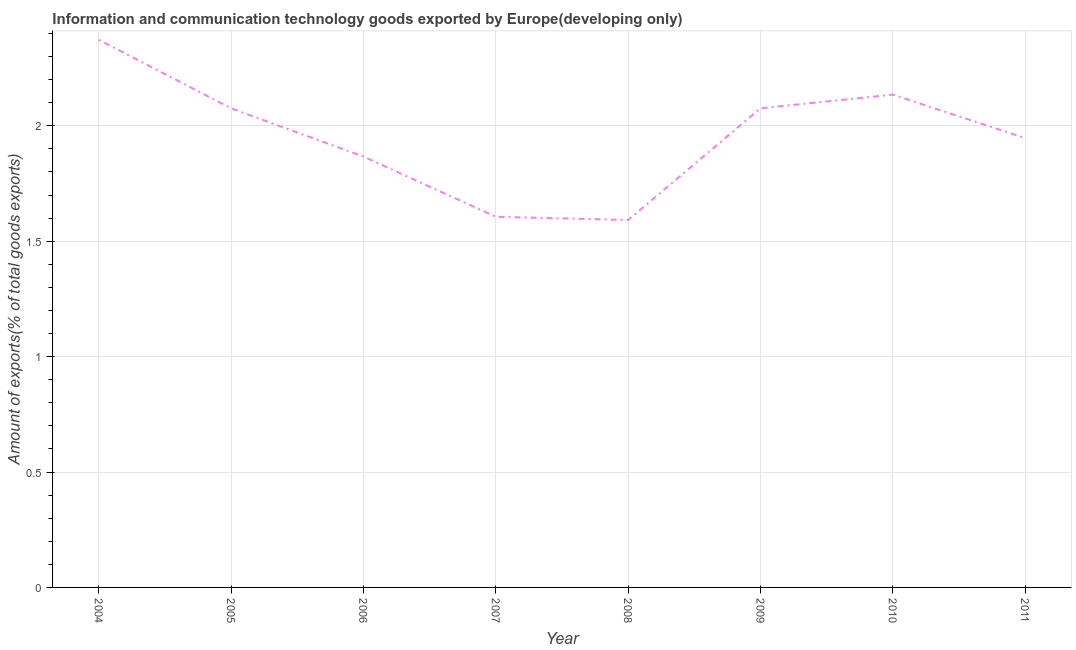What is the amount of ict goods exports in 2008?
Give a very brief answer. 1.59. Across all years, what is the maximum amount of ict goods exports?
Offer a very short reply. 2.37. Across all years, what is the minimum amount of ict goods exports?
Offer a terse response. 1.59. In which year was the amount of ict goods exports minimum?
Your answer should be very brief. 2008. What is the sum of the amount of ict goods exports?
Ensure brevity in your answer.  15.67. What is the difference between the amount of ict goods exports in 2004 and 2011?
Your response must be concise. 0.43. What is the average amount of ict goods exports per year?
Your answer should be very brief. 1.96. What is the median amount of ict goods exports?
Give a very brief answer. 2.01. What is the ratio of the amount of ict goods exports in 2007 to that in 2011?
Ensure brevity in your answer.  0.82. Is the amount of ict goods exports in 2006 less than that in 2011?
Your response must be concise. Yes. What is the difference between the highest and the second highest amount of ict goods exports?
Your answer should be very brief. 0.24. What is the difference between the highest and the lowest amount of ict goods exports?
Offer a terse response. 0.78. In how many years, is the amount of ict goods exports greater than the average amount of ict goods exports taken over all years?
Keep it short and to the point. 4. How many years are there in the graph?
Provide a succinct answer. 8. What is the difference between two consecutive major ticks on the Y-axis?
Keep it short and to the point. 0.5. Does the graph contain grids?
Keep it short and to the point. Yes. What is the title of the graph?
Offer a very short reply. Information and communication technology goods exported by Europe(developing only). What is the label or title of the X-axis?
Make the answer very short. Year. What is the label or title of the Y-axis?
Offer a very short reply. Amount of exports(% of total goods exports). What is the Amount of exports(% of total goods exports) of 2004?
Provide a succinct answer. 2.37. What is the Amount of exports(% of total goods exports) in 2005?
Make the answer very short. 2.08. What is the Amount of exports(% of total goods exports) in 2006?
Your response must be concise. 1.87. What is the Amount of exports(% of total goods exports) of 2007?
Provide a succinct answer. 1.61. What is the Amount of exports(% of total goods exports) in 2008?
Make the answer very short. 1.59. What is the Amount of exports(% of total goods exports) of 2009?
Give a very brief answer. 2.08. What is the Amount of exports(% of total goods exports) of 2010?
Your answer should be compact. 2.14. What is the Amount of exports(% of total goods exports) of 2011?
Your answer should be compact. 1.95. What is the difference between the Amount of exports(% of total goods exports) in 2004 and 2005?
Give a very brief answer. 0.3. What is the difference between the Amount of exports(% of total goods exports) in 2004 and 2006?
Keep it short and to the point. 0.51. What is the difference between the Amount of exports(% of total goods exports) in 2004 and 2007?
Provide a short and direct response. 0.77. What is the difference between the Amount of exports(% of total goods exports) in 2004 and 2008?
Offer a very short reply. 0.78. What is the difference between the Amount of exports(% of total goods exports) in 2004 and 2009?
Make the answer very short. 0.3. What is the difference between the Amount of exports(% of total goods exports) in 2004 and 2010?
Provide a succinct answer. 0.24. What is the difference between the Amount of exports(% of total goods exports) in 2004 and 2011?
Offer a terse response. 0.43. What is the difference between the Amount of exports(% of total goods exports) in 2005 and 2006?
Provide a succinct answer. 0.21. What is the difference between the Amount of exports(% of total goods exports) in 2005 and 2007?
Your response must be concise. 0.47. What is the difference between the Amount of exports(% of total goods exports) in 2005 and 2008?
Your answer should be compact. 0.48. What is the difference between the Amount of exports(% of total goods exports) in 2005 and 2009?
Make the answer very short. -0. What is the difference between the Amount of exports(% of total goods exports) in 2005 and 2010?
Your response must be concise. -0.06. What is the difference between the Amount of exports(% of total goods exports) in 2005 and 2011?
Your answer should be very brief. 0.13. What is the difference between the Amount of exports(% of total goods exports) in 2006 and 2007?
Your response must be concise. 0.26. What is the difference between the Amount of exports(% of total goods exports) in 2006 and 2008?
Your response must be concise. 0.27. What is the difference between the Amount of exports(% of total goods exports) in 2006 and 2009?
Keep it short and to the point. -0.21. What is the difference between the Amount of exports(% of total goods exports) in 2006 and 2010?
Provide a short and direct response. -0.27. What is the difference between the Amount of exports(% of total goods exports) in 2006 and 2011?
Your answer should be compact. -0.08. What is the difference between the Amount of exports(% of total goods exports) in 2007 and 2008?
Ensure brevity in your answer.  0.01. What is the difference between the Amount of exports(% of total goods exports) in 2007 and 2009?
Your answer should be compact. -0.47. What is the difference between the Amount of exports(% of total goods exports) in 2007 and 2010?
Make the answer very short. -0.53. What is the difference between the Amount of exports(% of total goods exports) in 2007 and 2011?
Offer a very short reply. -0.34. What is the difference between the Amount of exports(% of total goods exports) in 2008 and 2009?
Ensure brevity in your answer.  -0.48. What is the difference between the Amount of exports(% of total goods exports) in 2008 and 2010?
Your answer should be very brief. -0.54. What is the difference between the Amount of exports(% of total goods exports) in 2008 and 2011?
Make the answer very short. -0.35. What is the difference between the Amount of exports(% of total goods exports) in 2009 and 2010?
Your answer should be compact. -0.06. What is the difference between the Amount of exports(% of total goods exports) in 2009 and 2011?
Give a very brief answer. 0.13. What is the difference between the Amount of exports(% of total goods exports) in 2010 and 2011?
Provide a short and direct response. 0.19. What is the ratio of the Amount of exports(% of total goods exports) in 2004 to that in 2005?
Provide a short and direct response. 1.14. What is the ratio of the Amount of exports(% of total goods exports) in 2004 to that in 2006?
Make the answer very short. 1.27. What is the ratio of the Amount of exports(% of total goods exports) in 2004 to that in 2007?
Make the answer very short. 1.48. What is the ratio of the Amount of exports(% of total goods exports) in 2004 to that in 2008?
Provide a short and direct response. 1.49. What is the ratio of the Amount of exports(% of total goods exports) in 2004 to that in 2009?
Your answer should be very brief. 1.14. What is the ratio of the Amount of exports(% of total goods exports) in 2004 to that in 2010?
Offer a terse response. 1.11. What is the ratio of the Amount of exports(% of total goods exports) in 2004 to that in 2011?
Your answer should be very brief. 1.22. What is the ratio of the Amount of exports(% of total goods exports) in 2005 to that in 2006?
Your answer should be compact. 1.11. What is the ratio of the Amount of exports(% of total goods exports) in 2005 to that in 2007?
Provide a short and direct response. 1.29. What is the ratio of the Amount of exports(% of total goods exports) in 2005 to that in 2008?
Your response must be concise. 1.3. What is the ratio of the Amount of exports(% of total goods exports) in 2005 to that in 2010?
Your answer should be very brief. 0.97. What is the ratio of the Amount of exports(% of total goods exports) in 2005 to that in 2011?
Ensure brevity in your answer.  1.07. What is the ratio of the Amount of exports(% of total goods exports) in 2006 to that in 2007?
Your answer should be compact. 1.16. What is the ratio of the Amount of exports(% of total goods exports) in 2006 to that in 2008?
Keep it short and to the point. 1.17. What is the ratio of the Amount of exports(% of total goods exports) in 2006 to that in 2009?
Your answer should be very brief. 0.9. What is the ratio of the Amount of exports(% of total goods exports) in 2006 to that in 2010?
Offer a terse response. 0.87. What is the ratio of the Amount of exports(% of total goods exports) in 2006 to that in 2011?
Provide a short and direct response. 0.96. What is the ratio of the Amount of exports(% of total goods exports) in 2007 to that in 2008?
Provide a short and direct response. 1.01. What is the ratio of the Amount of exports(% of total goods exports) in 2007 to that in 2009?
Give a very brief answer. 0.77. What is the ratio of the Amount of exports(% of total goods exports) in 2007 to that in 2010?
Make the answer very short. 0.75. What is the ratio of the Amount of exports(% of total goods exports) in 2007 to that in 2011?
Your answer should be compact. 0.82. What is the ratio of the Amount of exports(% of total goods exports) in 2008 to that in 2009?
Provide a short and direct response. 0.77. What is the ratio of the Amount of exports(% of total goods exports) in 2008 to that in 2010?
Keep it short and to the point. 0.75. What is the ratio of the Amount of exports(% of total goods exports) in 2008 to that in 2011?
Your answer should be very brief. 0.82. What is the ratio of the Amount of exports(% of total goods exports) in 2009 to that in 2010?
Give a very brief answer. 0.97. What is the ratio of the Amount of exports(% of total goods exports) in 2009 to that in 2011?
Give a very brief answer. 1.07. What is the ratio of the Amount of exports(% of total goods exports) in 2010 to that in 2011?
Ensure brevity in your answer.  1.1. 